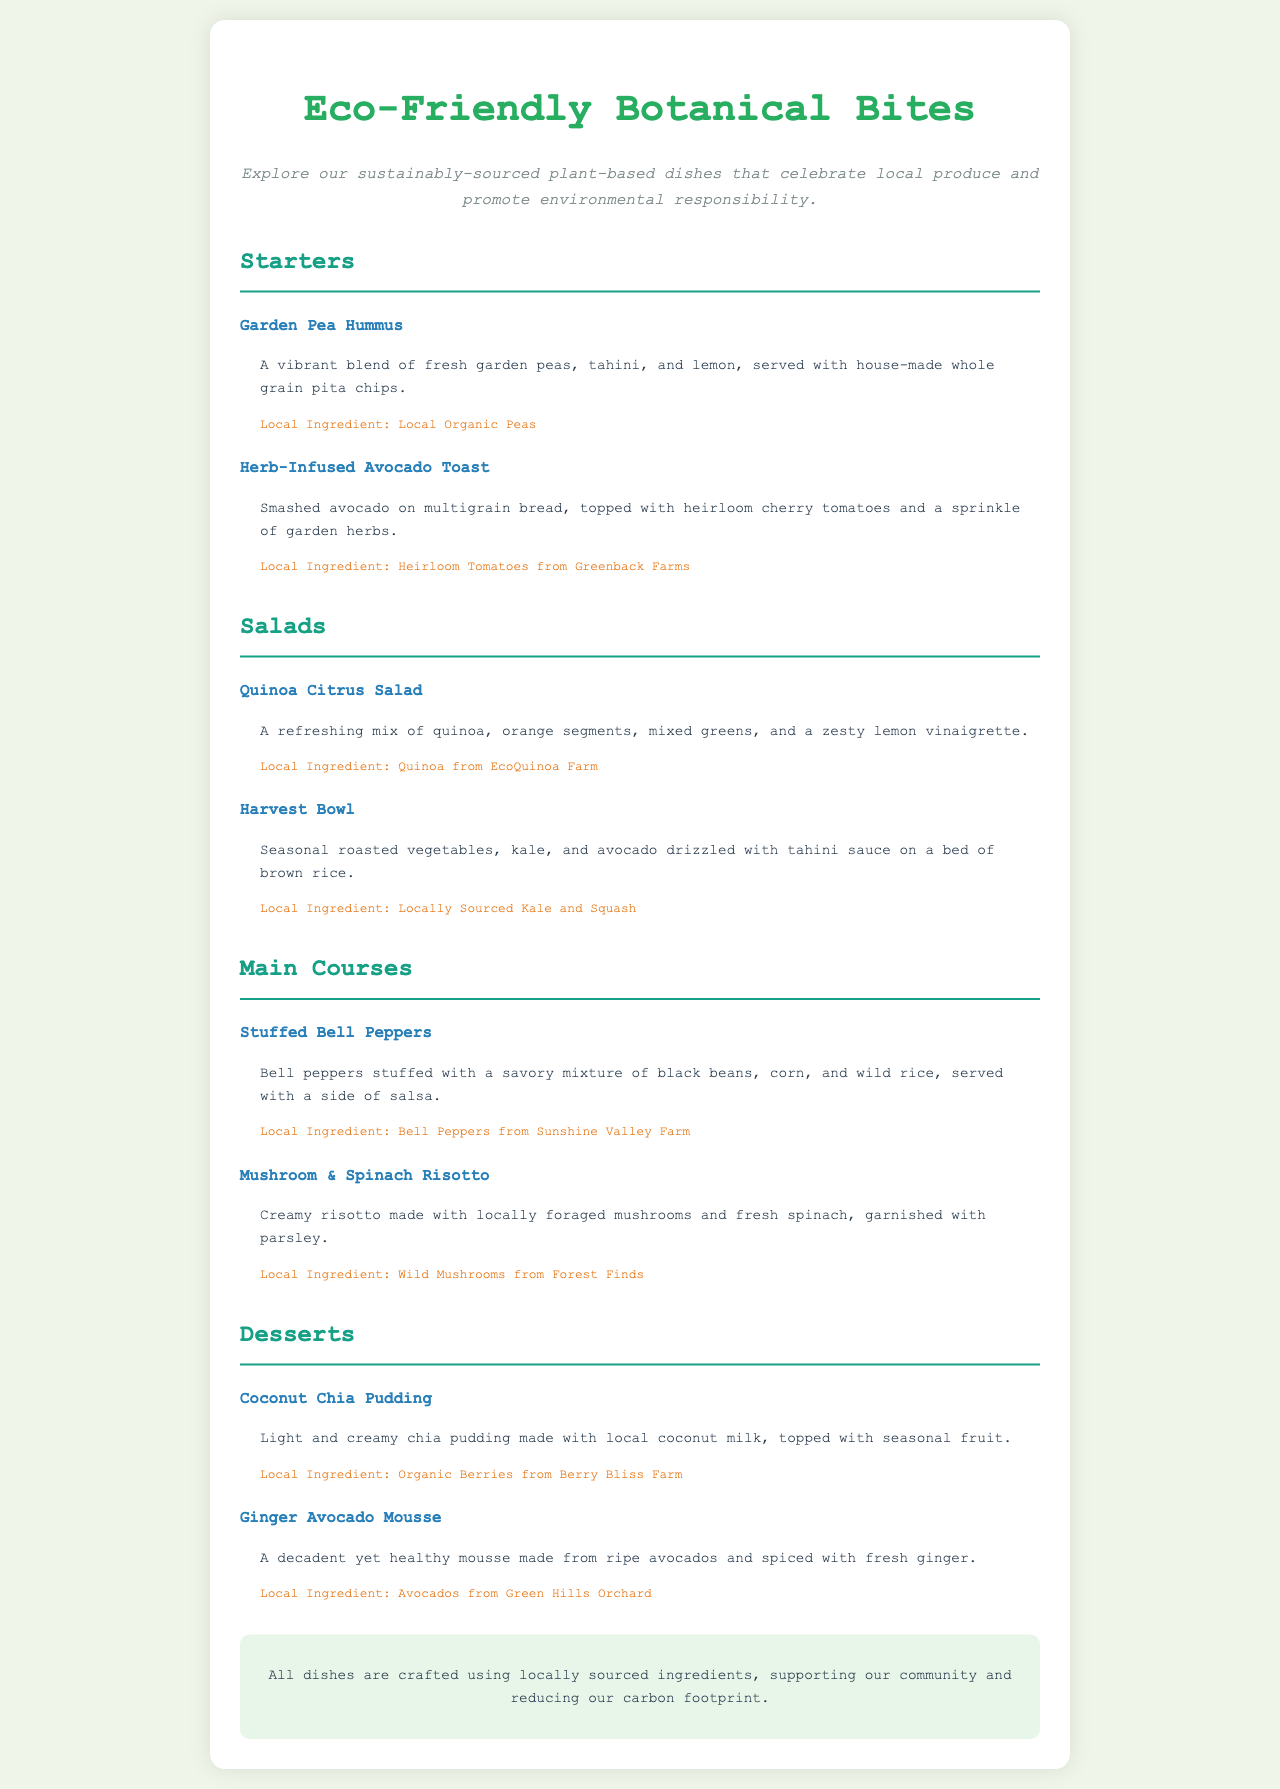What is the name of the first starter dish? The first starter dish is listed in the section for starters under "Starters."
Answer: Garden Pea Hummus How many salads are on the menu? The menu lists two different salads under the "Salads" section.
Answer: 2 What local ingredient is used in the Harvest Bowl? This information can be found next to the description of the Harvest Bowl in the salads section.
Answer: Locally Sourced Kale and Squash Which dessert is made from ripe avocados? The dessert made from ripe avocados is specified in the dessert section of the menu.
Answer: Ginger Avocado Mousse What type of milk is used in the Coconut Chia Pudding? The coconut milk used in the dessert is specified in the dish description for the Coconut Chia Pudding.
Answer: Local coconut milk What are the main ingredients in the Stuffed Bell Peppers? The main ingredients can be found in the description of the Stuffed Bell Peppers under main courses.
Answer: Black beans, corn, and wild rice 